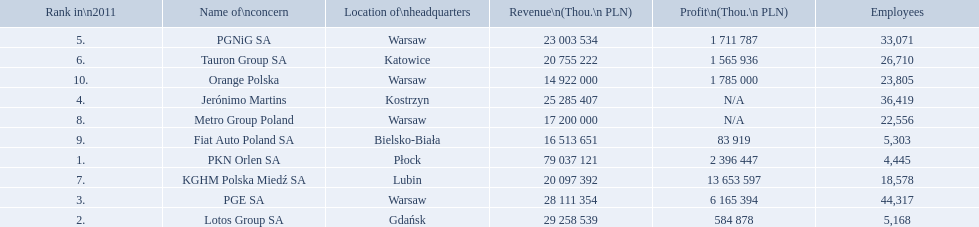What is the number of employees that work for pkn orlen sa in poland? 4,445. What number of employees work for lotos group sa? 5,168. How many people work for pgnig sa? 33,071. 